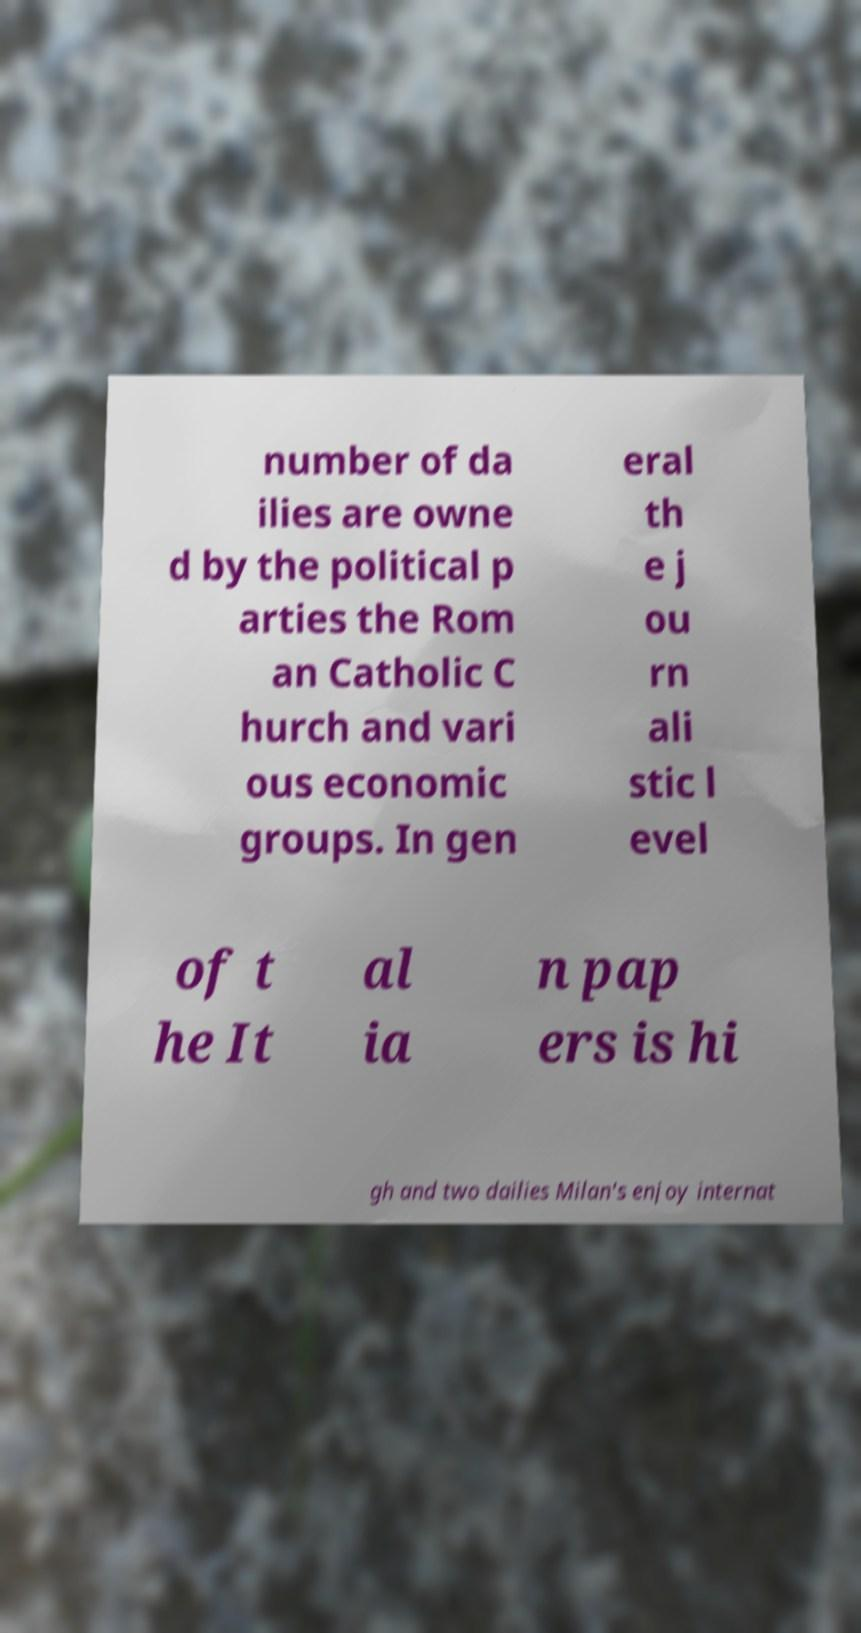Could you assist in decoding the text presented in this image and type it out clearly? number of da ilies are owne d by the political p arties the Rom an Catholic C hurch and vari ous economic groups. In gen eral th e j ou rn ali stic l evel of t he It al ia n pap ers is hi gh and two dailies Milan's enjoy internat 